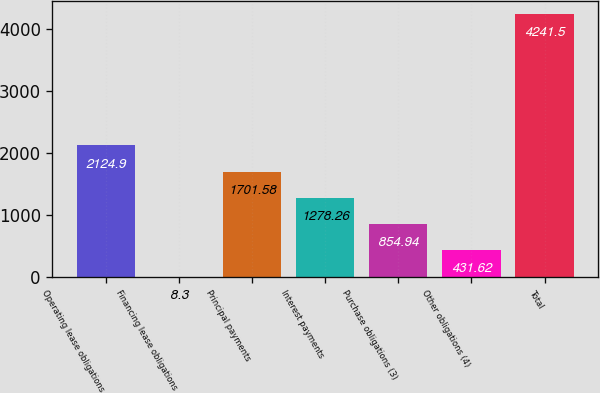<chart> <loc_0><loc_0><loc_500><loc_500><bar_chart><fcel>Operating lease obligations<fcel>Financing lease obligations<fcel>Principal payments<fcel>Interest payments<fcel>Purchase obligations (3)<fcel>Other obligations (4)<fcel>Total<nl><fcel>2124.9<fcel>8.3<fcel>1701.58<fcel>1278.26<fcel>854.94<fcel>431.62<fcel>4241.5<nl></chart> 